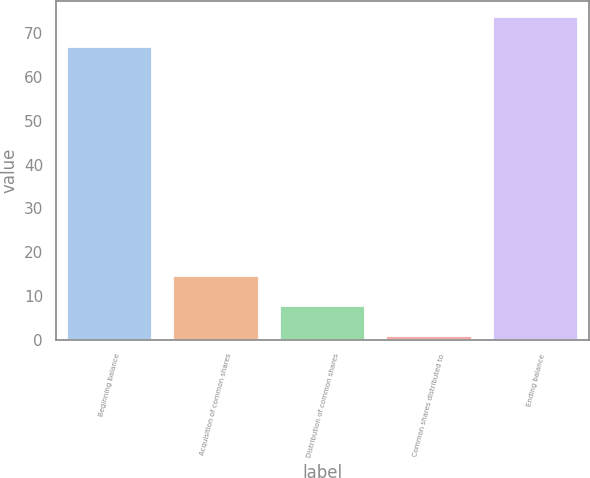<chart> <loc_0><loc_0><loc_500><loc_500><bar_chart><fcel>Beginning balance<fcel>Acquisition of common shares<fcel>Distribution of common shares<fcel>Common shares distributed to<fcel>Ending balance<nl><fcel>66.8<fcel>14.6<fcel>7.75<fcel>0.9<fcel>73.65<nl></chart> 